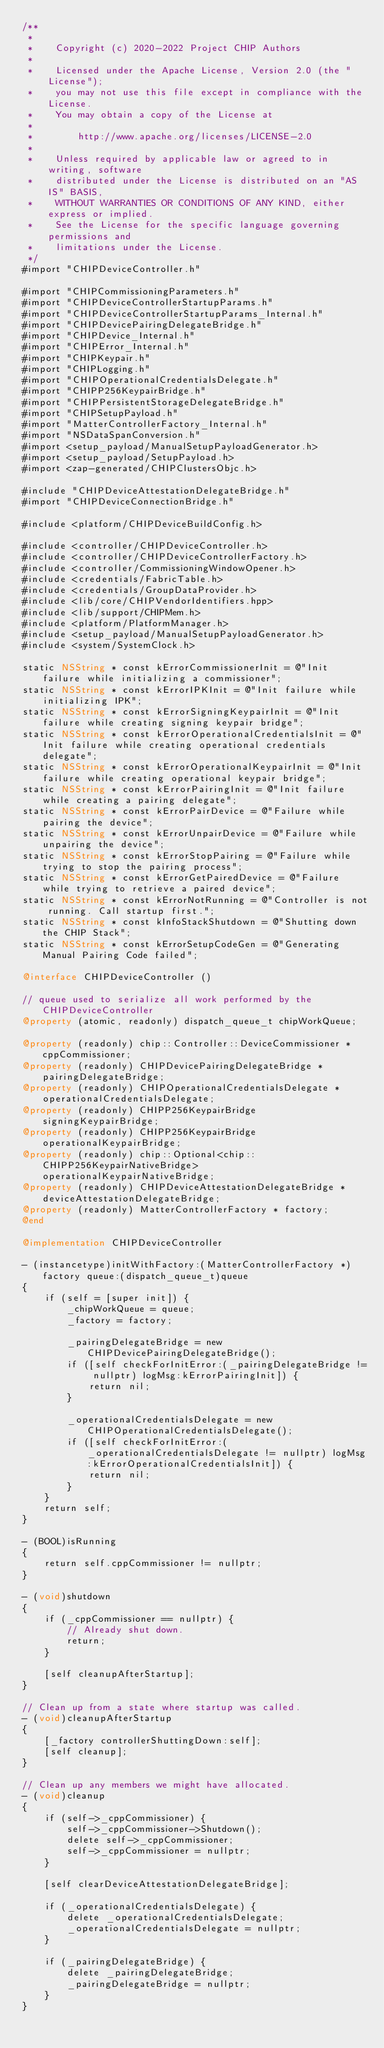Convert code to text. <code><loc_0><loc_0><loc_500><loc_500><_ObjectiveC_>/**
 *
 *    Copyright (c) 2020-2022 Project CHIP Authors
 *
 *    Licensed under the Apache License, Version 2.0 (the "License");
 *    you may not use this file except in compliance with the License.
 *    You may obtain a copy of the License at
 *
 *        http://www.apache.org/licenses/LICENSE-2.0
 *
 *    Unless required by applicable law or agreed to in writing, software
 *    distributed under the License is distributed on an "AS IS" BASIS,
 *    WITHOUT WARRANTIES OR CONDITIONS OF ANY KIND, either express or implied.
 *    See the License for the specific language governing permissions and
 *    limitations under the License.
 */
#import "CHIPDeviceController.h"

#import "CHIPCommissioningParameters.h"
#import "CHIPDeviceControllerStartupParams.h"
#import "CHIPDeviceControllerStartupParams_Internal.h"
#import "CHIPDevicePairingDelegateBridge.h"
#import "CHIPDevice_Internal.h"
#import "CHIPError_Internal.h"
#import "CHIPKeypair.h"
#import "CHIPLogging.h"
#import "CHIPOperationalCredentialsDelegate.h"
#import "CHIPP256KeypairBridge.h"
#import "CHIPPersistentStorageDelegateBridge.h"
#import "CHIPSetupPayload.h"
#import "MatterControllerFactory_Internal.h"
#import "NSDataSpanConversion.h"
#import <setup_payload/ManualSetupPayloadGenerator.h>
#import <setup_payload/SetupPayload.h>
#import <zap-generated/CHIPClustersObjc.h>

#include "CHIPDeviceAttestationDelegateBridge.h"
#import "CHIPDeviceConnectionBridge.h"

#include <platform/CHIPDeviceBuildConfig.h>

#include <controller/CHIPDeviceController.h>
#include <controller/CHIPDeviceControllerFactory.h>
#include <controller/CommissioningWindowOpener.h>
#include <credentials/FabricTable.h>
#include <credentials/GroupDataProvider.h>
#include <lib/core/CHIPVendorIdentifiers.hpp>
#include <lib/support/CHIPMem.h>
#include <platform/PlatformManager.h>
#include <setup_payload/ManualSetupPayloadGenerator.h>
#include <system/SystemClock.h>

static NSString * const kErrorCommissionerInit = @"Init failure while initializing a commissioner";
static NSString * const kErrorIPKInit = @"Init failure while initializing IPK";
static NSString * const kErrorSigningKeypairInit = @"Init failure while creating signing keypair bridge";
static NSString * const kErrorOperationalCredentialsInit = @"Init failure while creating operational credentials delegate";
static NSString * const kErrorOperationalKeypairInit = @"Init failure while creating operational keypair bridge";
static NSString * const kErrorPairingInit = @"Init failure while creating a pairing delegate";
static NSString * const kErrorPairDevice = @"Failure while pairing the device";
static NSString * const kErrorUnpairDevice = @"Failure while unpairing the device";
static NSString * const kErrorStopPairing = @"Failure while trying to stop the pairing process";
static NSString * const kErrorGetPairedDevice = @"Failure while trying to retrieve a paired device";
static NSString * const kErrorNotRunning = @"Controller is not running. Call startup first.";
static NSString * const kInfoStackShutdown = @"Shutting down the CHIP Stack";
static NSString * const kErrorSetupCodeGen = @"Generating Manual Pairing Code failed";

@interface CHIPDeviceController ()

// queue used to serialize all work performed by the CHIPDeviceController
@property (atomic, readonly) dispatch_queue_t chipWorkQueue;

@property (readonly) chip::Controller::DeviceCommissioner * cppCommissioner;
@property (readonly) CHIPDevicePairingDelegateBridge * pairingDelegateBridge;
@property (readonly) CHIPOperationalCredentialsDelegate * operationalCredentialsDelegate;
@property (readonly) CHIPP256KeypairBridge signingKeypairBridge;
@property (readonly) CHIPP256KeypairBridge operationalKeypairBridge;
@property (readonly) chip::Optional<chip::CHIPP256KeypairNativeBridge> operationalKeypairNativeBridge;
@property (readonly) CHIPDeviceAttestationDelegateBridge * deviceAttestationDelegateBridge;
@property (readonly) MatterControllerFactory * factory;
@end

@implementation CHIPDeviceController

- (instancetype)initWithFactory:(MatterControllerFactory *)factory queue:(dispatch_queue_t)queue
{
    if (self = [super init]) {
        _chipWorkQueue = queue;
        _factory = factory;

        _pairingDelegateBridge = new CHIPDevicePairingDelegateBridge();
        if ([self checkForInitError:(_pairingDelegateBridge != nullptr) logMsg:kErrorPairingInit]) {
            return nil;
        }

        _operationalCredentialsDelegate = new CHIPOperationalCredentialsDelegate();
        if ([self checkForInitError:(_operationalCredentialsDelegate != nullptr) logMsg:kErrorOperationalCredentialsInit]) {
            return nil;
        }
    }
    return self;
}

- (BOOL)isRunning
{
    return self.cppCommissioner != nullptr;
}

- (void)shutdown
{
    if (_cppCommissioner == nullptr) {
        // Already shut down.
        return;
    }

    [self cleanupAfterStartup];
}

// Clean up from a state where startup was called.
- (void)cleanupAfterStartup
{
    [_factory controllerShuttingDown:self];
    [self cleanup];
}

// Clean up any members we might have allocated.
- (void)cleanup
{
    if (self->_cppCommissioner) {
        self->_cppCommissioner->Shutdown();
        delete self->_cppCommissioner;
        self->_cppCommissioner = nullptr;
    }

    [self clearDeviceAttestationDelegateBridge];

    if (_operationalCredentialsDelegate) {
        delete _operationalCredentialsDelegate;
        _operationalCredentialsDelegate = nullptr;
    }

    if (_pairingDelegateBridge) {
        delete _pairingDelegateBridge;
        _pairingDelegateBridge = nullptr;
    }
}
</code> 